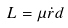Convert formula to latex. <formula><loc_0><loc_0><loc_500><loc_500>L = \mu \dot { r } d</formula> 